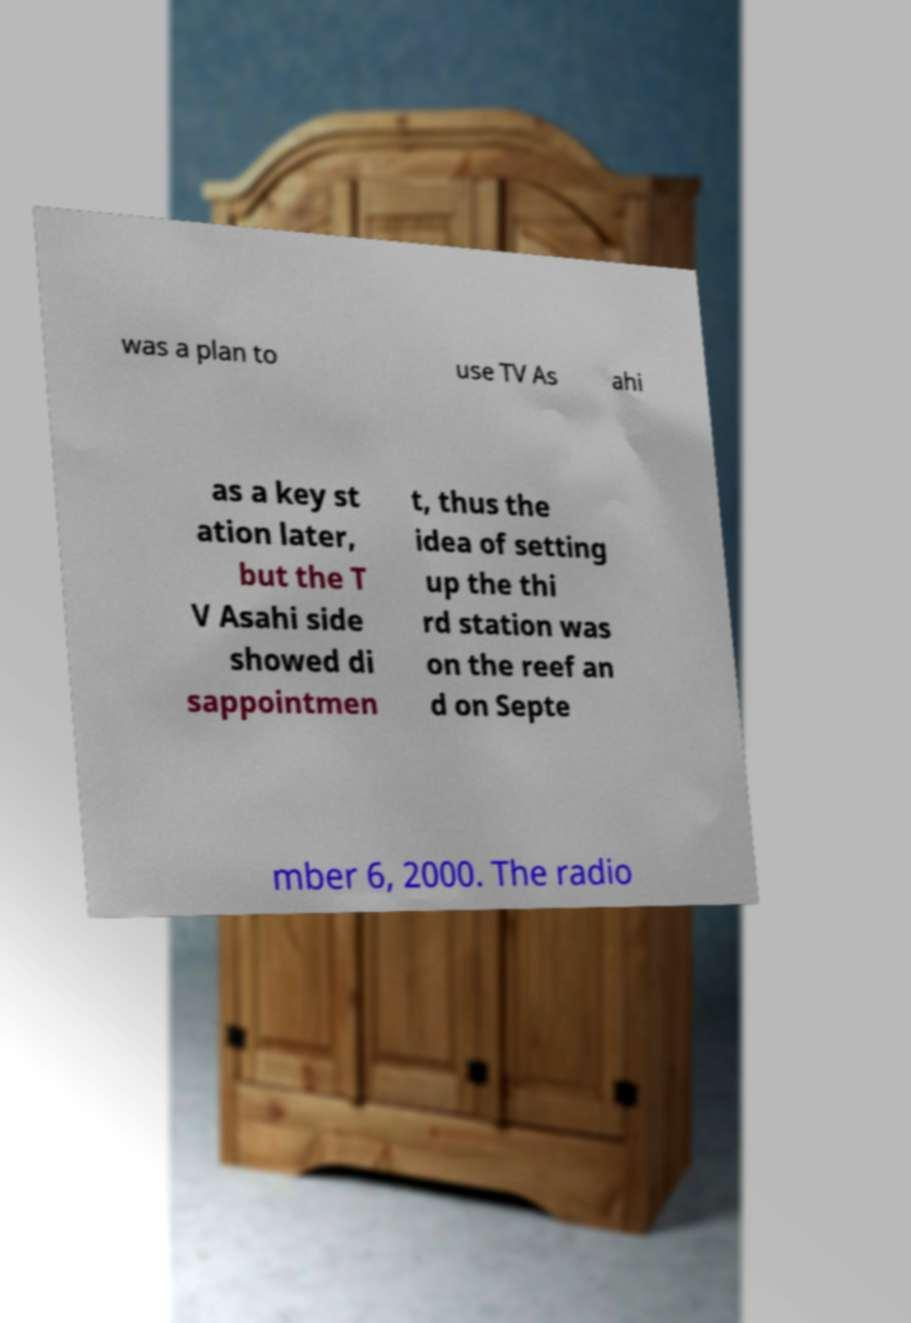Please identify and transcribe the text found in this image. was a plan to use TV As ahi as a key st ation later, but the T V Asahi side showed di sappointmen t, thus the idea of setting up the thi rd station was on the reef an d on Septe mber 6, 2000. The radio 